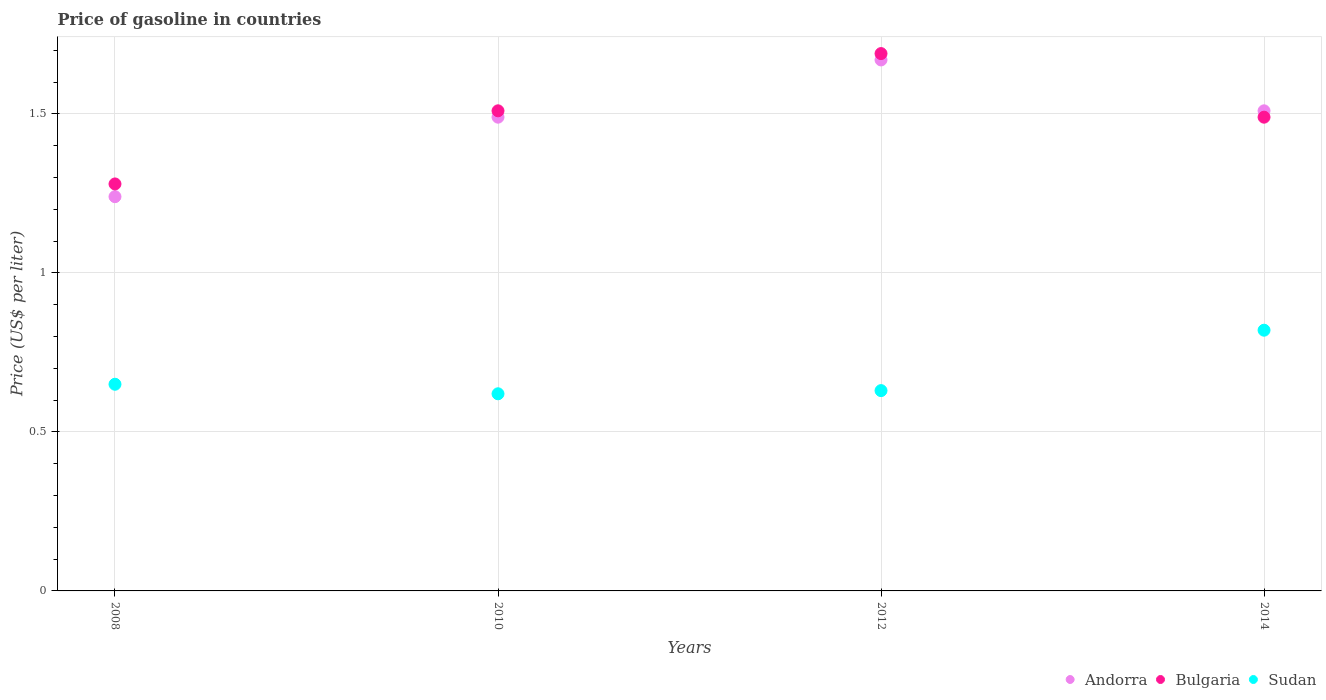What is the price of gasoline in Andorra in 2012?
Provide a succinct answer. 1.67. Across all years, what is the maximum price of gasoline in Andorra?
Keep it short and to the point. 1.67. Across all years, what is the minimum price of gasoline in Andorra?
Make the answer very short. 1.24. What is the total price of gasoline in Sudan in the graph?
Keep it short and to the point. 2.72. What is the difference between the price of gasoline in Bulgaria in 2008 and that in 2012?
Make the answer very short. -0.41. What is the difference between the price of gasoline in Bulgaria in 2012 and the price of gasoline in Sudan in 2010?
Keep it short and to the point. 1.07. What is the average price of gasoline in Sudan per year?
Give a very brief answer. 0.68. In the year 2008, what is the difference between the price of gasoline in Andorra and price of gasoline in Bulgaria?
Provide a succinct answer. -0.04. What is the ratio of the price of gasoline in Sudan in 2010 to that in 2014?
Provide a succinct answer. 0.76. Is the price of gasoline in Andorra in 2010 less than that in 2014?
Give a very brief answer. Yes. What is the difference between the highest and the second highest price of gasoline in Andorra?
Ensure brevity in your answer.  0.16. What is the difference between the highest and the lowest price of gasoline in Bulgaria?
Your answer should be very brief. 0.41. Is it the case that in every year, the sum of the price of gasoline in Andorra and price of gasoline in Sudan  is greater than the price of gasoline in Bulgaria?
Provide a succinct answer. Yes. Is the price of gasoline in Bulgaria strictly greater than the price of gasoline in Andorra over the years?
Give a very brief answer. No. Is the price of gasoline in Bulgaria strictly less than the price of gasoline in Andorra over the years?
Ensure brevity in your answer.  No. How many dotlines are there?
Your response must be concise. 3. Are the values on the major ticks of Y-axis written in scientific E-notation?
Give a very brief answer. No. Does the graph contain any zero values?
Keep it short and to the point. No. How many legend labels are there?
Offer a terse response. 3. What is the title of the graph?
Give a very brief answer. Price of gasoline in countries. What is the label or title of the Y-axis?
Ensure brevity in your answer.  Price (US$ per liter). What is the Price (US$ per liter) of Andorra in 2008?
Make the answer very short. 1.24. What is the Price (US$ per liter) in Bulgaria in 2008?
Provide a short and direct response. 1.28. What is the Price (US$ per liter) of Sudan in 2008?
Give a very brief answer. 0.65. What is the Price (US$ per liter) of Andorra in 2010?
Offer a very short reply. 1.49. What is the Price (US$ per liter) in Bulgaria in 2010?
Ensure brevity in your answer.  1.51. What is the Price (US$ per liter) of Sudan in 2010?
Your answer should be very brief. 0.62. What is the Price (US$ per liter) of Andorra in 2012?
Give a very brief answer. 1.67. What is the Price (US$ per liter) in Bulgaria in 2012?
Provide a short and direct response. 1.69. What is the Price (US$ per liter) of Sudan in 2012?
Provide a succinct answer. 0.63. What is the Price (US$ per liter) in Andorra in 2014?
Provide a short and direct response. 1.51. What is the Price (US$ per liter) of Bulgaria in 2014?
Offer a terse response. 1.49. What is the Price (US$ per liter) of Sudan in 2014?
Make the answer very short. 0.82. Across all years, what is the maximum Price (US$ per liter) of Andorra?
Keep it short and to the point. 1.67. Across all years, what is the maximum Price (US$ per liter) of Bulgaria?
Provide a short and direct response. 1.69. Across all years, what is the maximum Price (US$ per liter) of Sudan?
Make the answer very short. 0.82. Across all years, what is the minimum Price (US$ per liter) in Andorra?
Your response must be concise. 1.24. Across all years, what is the minimum Price (US$ per liter) of Bulgaria?
Make the answer very short. 1.28. Across all years, what is the minimum Price (US$ per liter) of Sudan?
Provide a short and direct response. 0.62. What is the total Price (US$ per liter) of Andorra in the graph?
Keep it short and to the point. 5.91. What is the total Price (US$ per liter) of Bulgaria in the graph?
Your response must be concise. 5.97. What is the total Price (US$ per liter) of Sudan in the graph?
Your response must be concise. 2.72. What is the difference between the Price (US$ per liter) in Bulgaria in 2008 and that in 2010?
Make the answer very short. -0.23. What is the difference between the Price (US$ per liter) of Sudan in 2008 and that in 2010?
Your answer should be very brief. 0.03. What is the difference between the Price (US$ per liter) in Andorra in 2008 and that in 2012?
Ensure brevity in your answer.  -0.43. What is the difference between the Price (US$ per liter) of Bulgaria in 2008 and that in 2012?
Offer a very short reply. -0.41. What is the difference between the Price (US$ per liter) in Andorra in 2008 and that in 2014?
Make the answer very short. -0.27. What is the difference between the Price (US$ per liter) in Bulgaria in 2008 and that in 2014?
Ensure brevity in your answer.  -0.21. What is the difference between the Price (US$ per liter) in Sudan in 2008 and that in 2014?
Provide a succinct answer. -0.17. What is the difference between the Price (US$ per liter) of Andorra in 2010 and that in 2012?
Give a very brief answer. -0.18. What is the difference between the Price (US$ per liter) of Bulgaria in 2010 and that in 2012?
Keep it short and to the point. -0.18. What is the difference between the Price (US$ per liter) of Sudan in 2010 and that in 2012?
Ensure brevity in your answer.  -0.01. What is the difference between the Price (US$ per liter) of Andorra in 2010 and that in 2014?
Make the answer very short. -0.02. What is the difference between the Price (US$ per liter) of Bulgaria in 2010 and that in 2014?
Offer a terse response. 0.02. What is the difference between the Price (US$ per liter) in Andorra in 2012 and that in 2014?
Give a very brief answer. 0.16. What is the difference between the Price (US$ per liter) of Sudan in 2012 and that in 2014?
Your answer should be compact. -0.19. What is the difference between the Price (US$ per liter) in Andorra in 2008 and the Price (US$ per liter) in Bulgaria in 2010?
Provide a short and direct response. -0.27. What is the difference between the Price (US$ per liter) in Andorra in 2008 and the Price (US$ per liter) in Sudan in 2010?
Offer a very short reply. 0.62. What is the difference between the Price (US$ per liter) of Bulgaria in 2008 and the Price (US$ per liter) of Sudan in 2010?
Provide a succinct answer. 0.66. What is the difference between the Price (US$ per liter) of Andorra in 2008 and the Price (US$ per liter) of Bulgaria in 2012?
Make the answer very short. -0.45. What is the difference between the Price (US$ per liter) in Andorra in 2008 and the Price (US$ per liter) in Sudan in 2012?
Offer a terse response. 0.61. What is the difference between the Price (US$ per liter) of Bulgaria in 2008 and the Price (US$ per liter) of Sudan in 2012?
Give a very brief answer. 0.65. What is the difference between the Price (US$ per liter) in Andorra in 2008 and the Price (US$ per liter) in Sudan in 2014?
Give a very brief answer. 0.42. What is the difference between the Price (US$ per liter) in Bulgaria in 2008 and the Price (US$ per liter) in Sudan in 2014?
Provide a succinct answer. 0.46. What is the difference between the Price (US$ per liter) in Andorra in 2010 and the Price (US$ per liter) in Bulgaria in 2012?
Provide a succinct answer. -0.2. What is the difference between the Price (US$ per liter) of Andorra in 2010 and the Price (US$ per liter) of Sudan in 2012?
Your answer should be compact. 0.86. What is the difference between the Price (US$ per liter) of Bulgaria in 2010 and the Price (US$ per liter) of Sudan in 2012?
Your answer should be very brief. 0.88. What is the difference between the Price (US$ per liter) in Andorra in 2010 and the Price (US$ per liter) in Sudan in 2014?
Ensure brevity in your answer.  0.67. What is the difference between the Price (US$ per liter) of Bulgaria in 2010 and the Price (US$ per liter) of Sudan in 2014?
Keep it short and to the point. 0.69. What is the difference between the Price (US$ per liter) in Andorra in 2012 and the Price (US$ per liter) in Bulgaria in 2014?
Provide a short and direct response. 0.18. What is the difference between the Price (US$ per liter) of Bulgaria in 2012 and the Price (US$ per liter) of Sudan in 2014?
Ensure brevity in your answer.  0.87. What is the average Price (US$ per liter) in Andorra per year?
Keep it short and to the point. 1.48. What is the average Price (US$ per liter) of Bulgaria per year?
Offer a very short reply. 1.49. What is the average Price (US$ per liter) of Sudan per year?
Make the answer very short. 0.68. In the year 2008, what is the difference between the Price (US$ per liter) in Andorra and Price (US$ per liter) in Bulgaria?
Keep it short and to the point. -0.04. In the year 2008, what is the difference between the Price (US$ per liter) in Andorra and Price (US$ per liter) in Sudan?
Give a very brief answer. 0.59. In the year 2008, what is the difference between the Price (US$ per liter) in Bulgaria and Price (US$ per liter) in Sudan?
Offer a terse response. 0.63. In the year 2010, what is the difference between the Price (US$ per liter) in Andorra and Price (US$ per liter) in Bulgaria?
Offer a very short reply. -0.02. In the year 2010, what is the difference between the Price (US$ per liter) of Andorra and Price (US$ per liter) of Sudan?
Give a very brief answer. 0.87. In the year 2010, what is the difference between the Price (US$ per liter) of Bulgaria and Price (US$ per liter) of Sudan?
Offer a terse response. 0.89. In the year 2012, what is the difference between the Price (US$ per liter) of Andorra and Price (US$ per liter) of Bulgaria?
Your answer should be compact. -0.02. In the year 2012, what is the difference between the Price (US$ per liter) of Andorra and Price (US$ per liter) of Sudan?
Provide a short and direct response. 1.04. In the year 2012, what is the difference between the Price (US$ per liter) of Bulgaria and Price (US$ per liter) of Sudan?
Ensure brevity in your answer.  1.06. In the year 2014, what is the difference between the Price (US$ per liter) of Andorra and Price (US$ per liter) of Bulgaria?
Provide a succinct answer. 0.02. In the year 2014, what is the difference between the Price (US$ per liter) in Andorra and Price (US$ per liter) in Sudan?
Provide a short and direct response. 0.69. In the year 2014, what is the difference between the Price (US$ per liter) in Bulgaria and Price (US$ per liter) in Sudan?
Offer a very short reply. 0.67. What is the ratio of the Price (US$ per liter) in Andorra in 2008 to that in 2010?
Your answer should be compact. 0.83. What is the ratio of the Price (US$ per liter) in Bulgaria in 2008 to that in 2010?
Offer a very short reply. 0.85. What is the ratio of the Price (US$ per liter) of Sudan in 2008 to that in 2010?
Provide a succinct answer. 1.05. What is the ratio of the Price (US$ per liter) of Andorra in 2008 to that in 2012?
Keep it short and to the point. 0.74. What is the ratio of the Price (US$ per liter) in Bulgaria in 2008 to that in 2012?
Provide a succinct answer. 0.76. What is the ratio of the Price (US$ per liter) of Sudan in 2008 to that in 2012?
Ensure brevity in your answer.  1.03. What is the ratio of the Price (US$ per liter) in Andorra in 2008 to that in 2014?
Offer a terse response. 0.82. What is the ratio of the Price (US$ per liter) in Bulgaria in 2008 to that in 2014?
Your response must be concise. 0.86. What is the ratio of the Price (US$ per liter) of Sudan in 2008 to that in 2014?
Provide a short and direct response. 0.79. What is the ratio of the Price (US$ per liter) of Andorra in 2010 to that in 2012?
Provide a short and direct response. 0.89. What is the ratio of the Price (US$ per liter) in Bulgaria in 2010 to that in 2012?
Keep it short and to the point. 0.89. What is the ratio of the Price (US$ per liter) in Sudan in 2010 to that in 2012?
Offer a terse response. 0.98. What is the ratio of the Price (US$ per liter) in Andorra in 2010 to that in 2014?
Ensure brevity in your answer.  0.99. What is the ratio of the Price (US$ per liter) of Bulgaria in 2010 to that in 2014?
Offer a very short reply. 1.01. What is the ratio of the Price (US$ per liter) of Sudan in 2010 to that in 2014?
Provide a short and direct response. 0.76. What is the ratio of the Price (US$ per liter) in Andorra in 2012 to that in 2014?
Keep it short and to the point. 1.11. What is the ratio of the Price (US$ per liter) in Bulgaria in 2012 to that in 2014?
Offer a very short reply. 1.13. What is the ratio of the Price (US$ per liter) of Sudan in 2012 to that in 2014?
Make the answer very short. 0.77. What is the difference between the highest and the second highest Price (US$ per liter) in Andorra?
Keep it short and to the point. 0.16. What is the difference between the highest and the second highest Price (US$ per liter) of Bulgaria?
Provide a short and direct response. 0.18. What is the difference between the highest and the second highest Price (US$ per liter) of Sudan?
Keep it short and to the point. 0.17. What is the difference between the highest and the lowest Price (US$ per liter) of Andorra?
Offer a terse response. 0.43. What is the difference between the highest and the lowest Price (US$ per liter) of Bulgaria?
Your answer should be compact. 0.41. What is the difference between the highest and the lowest Price (US$ per liter) of Sudan?
Your answer should be compact. 0.2. 